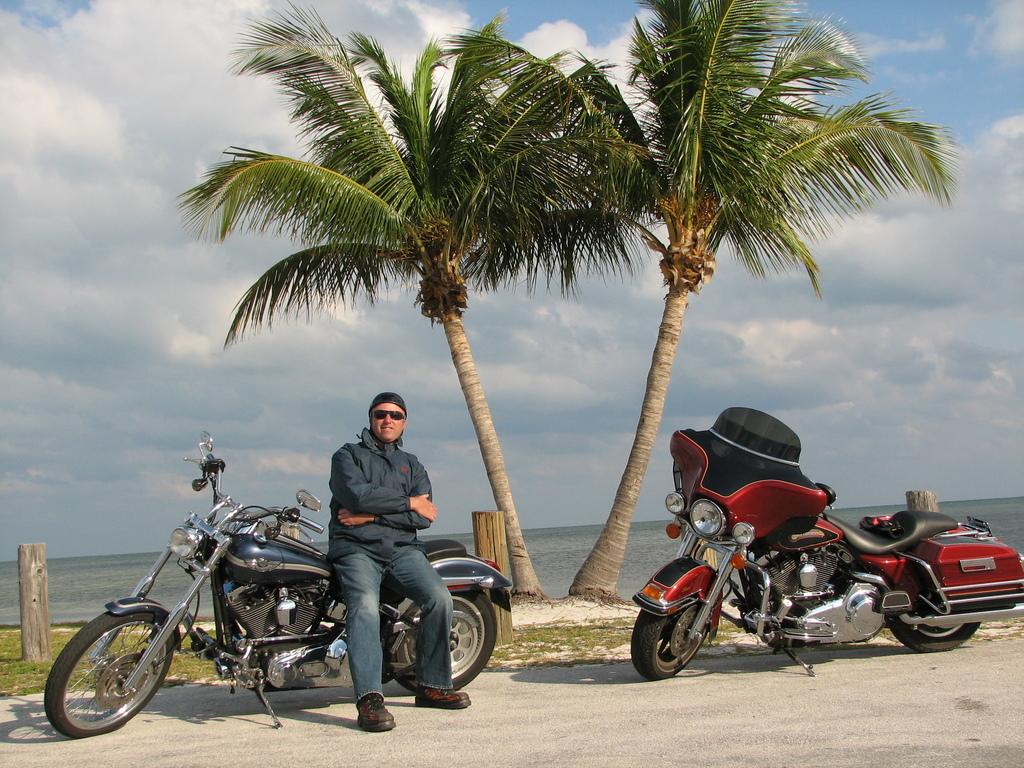Who is present in the image? There is a man in the image. What objects can be seen in the image besides the man? There are two bikes in the image. What can be seen in the background of the image? There are two trees and a cloudy sky in the background of the image. What type of fiction is the man reading in the image? There is no book or any indication of reading in the image, so it cannot be determined if the man is reading fiction or any other type of material. 